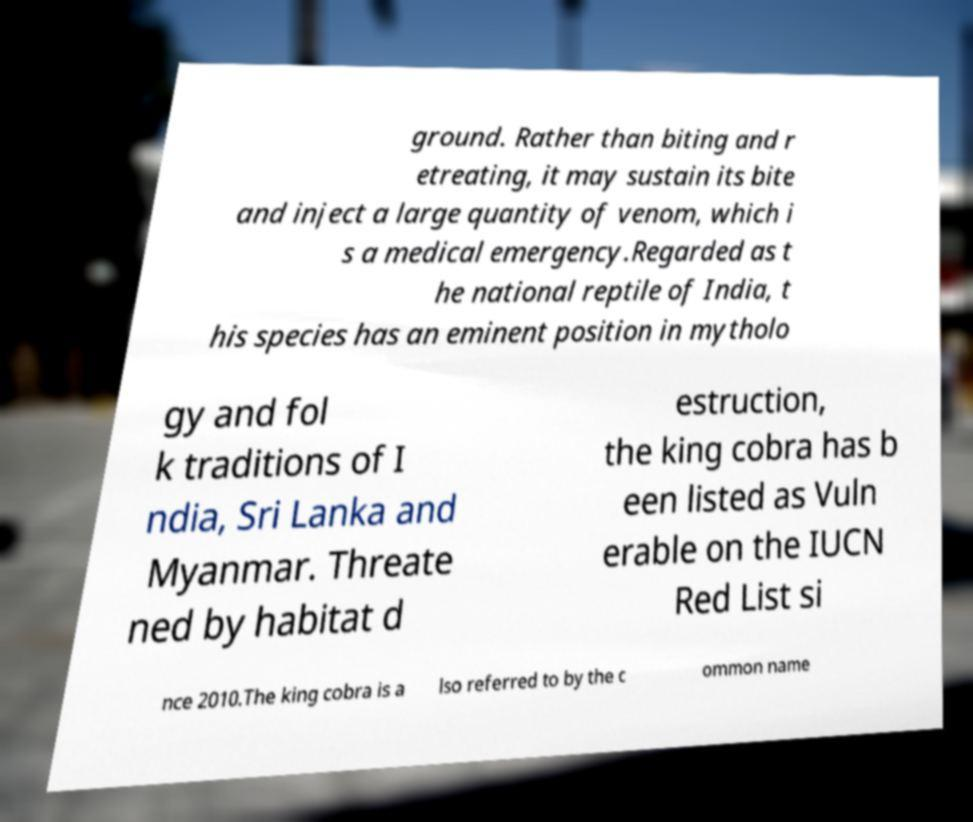Can you read and provide the text displayed in the image?This photo seems to have some interesting text. Can you extract and type it out for me? ground. Rather than biting and r etreating, it may sustain its bite and inject a large quantity of venom, which i s a medical emergency.Regarded as t he national reptile of India, t his species has an eminent position in mytholo gy and fol k traditions of I ndia, Sri Lanka and Myanmar. Threate ned by habitat d estruction, the king cobra has b een listed as Vuln erable on the IUCN Red List si nce 2010.The king cobra is a lso referred to by the c ommon name 